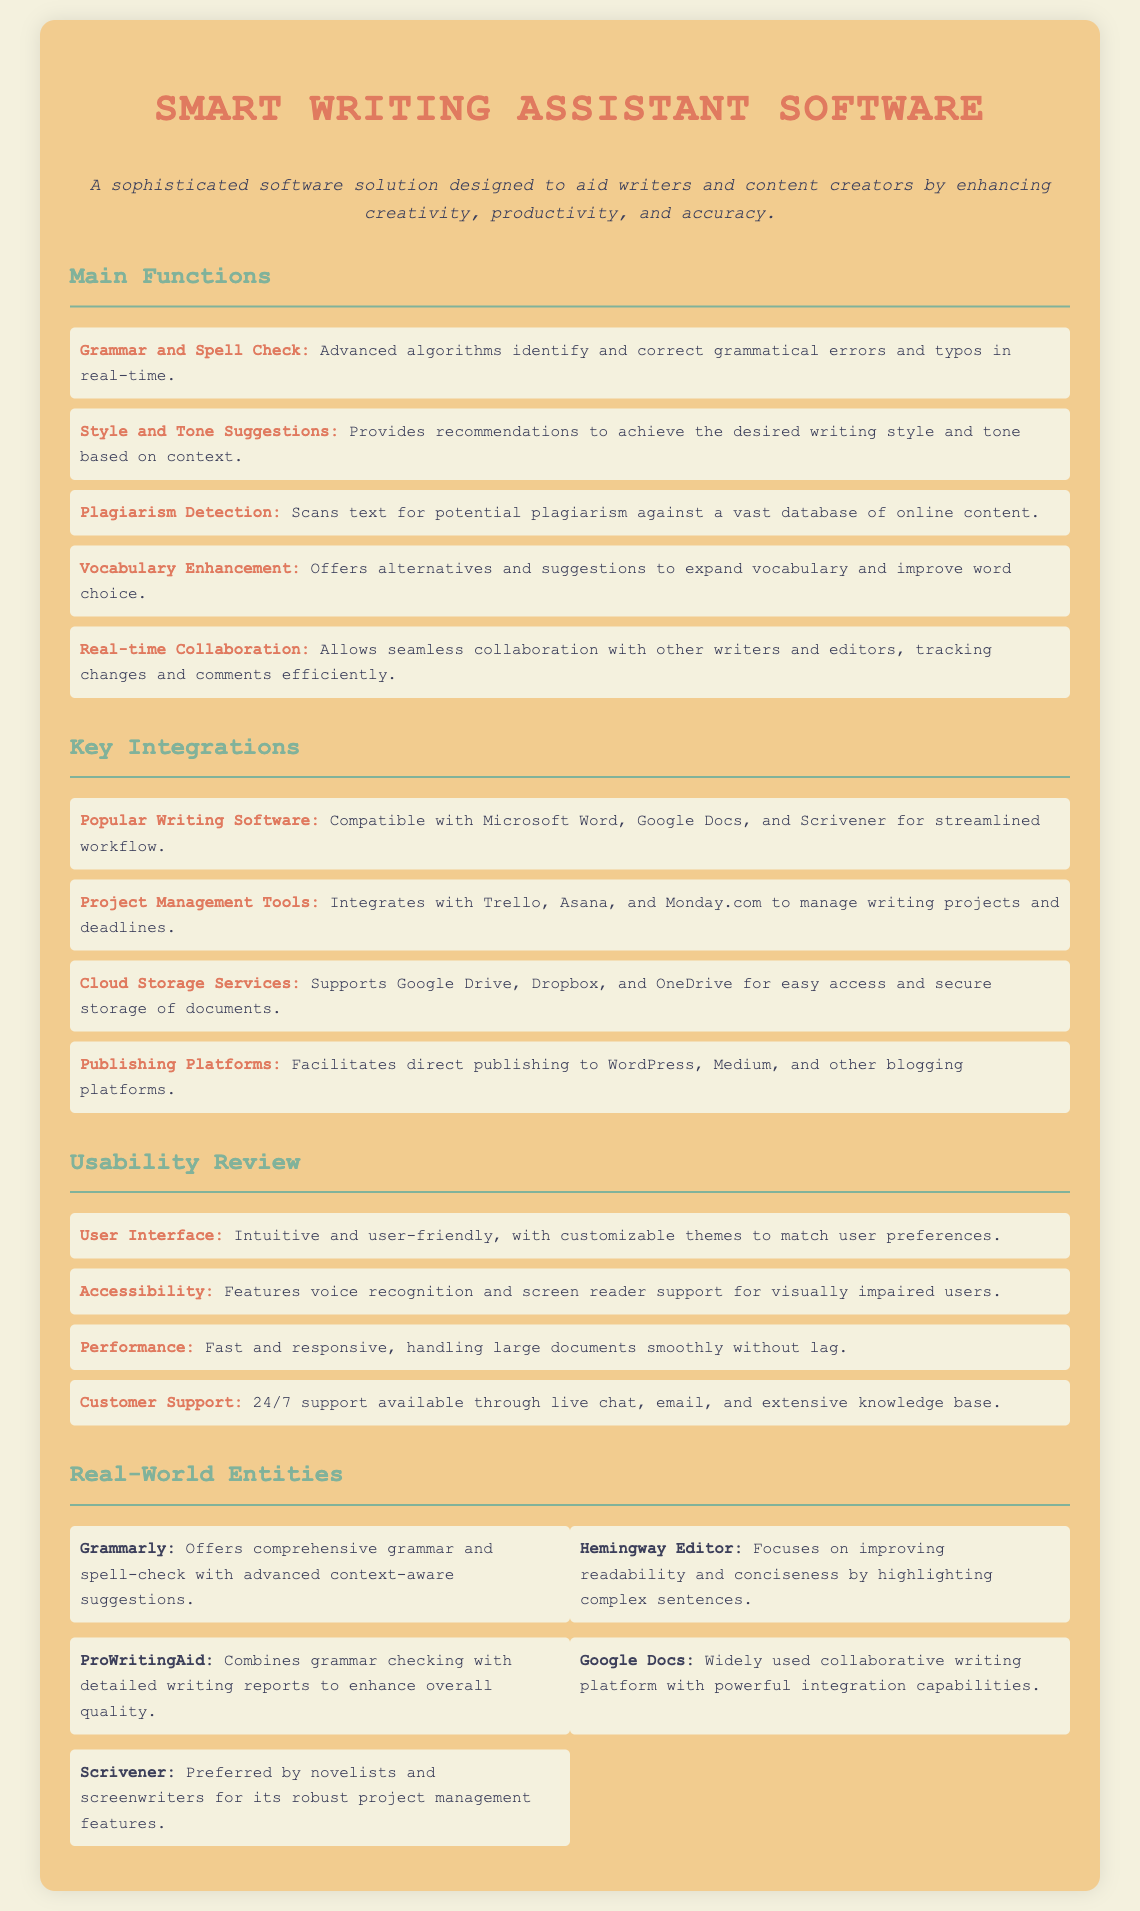What is the main purpose of the software? The document states that the software is designed to aid writers and content creators by enhancing creativity, productivity, and accuracy.
Answer: Aid writers and content creators How many main functions are listed? The document enumerates five main functions of the software.
Answer: Five What does the software support for storage? The software integrates with various cloud storage services for easy access and secure storage of documents.
Answer: Google Drive, Dropbox, and OneDrive What type of support is available for customers? The document specifies that customer support is available 24/7 through multiple channels.
Answer: 24/7 support Which writing software is mentioned as compatible? The document lists Microsoft Word as one of the compatible popular writing software.
Answer: Microsoft Word What feature helps visually impaired users? The software includes features specifically designed to assist visually impaired users.
Answer: Screen reader support Which platform focuses on improving readability? The document mentions Hemingway Editor as focusing on improving readability and conciseness.
Answer: Hemingway Editor What is the style of the user interface described? The user interface is described as intuitive and user-friendly in the document.
Answer: Intuitive and user-friendly 